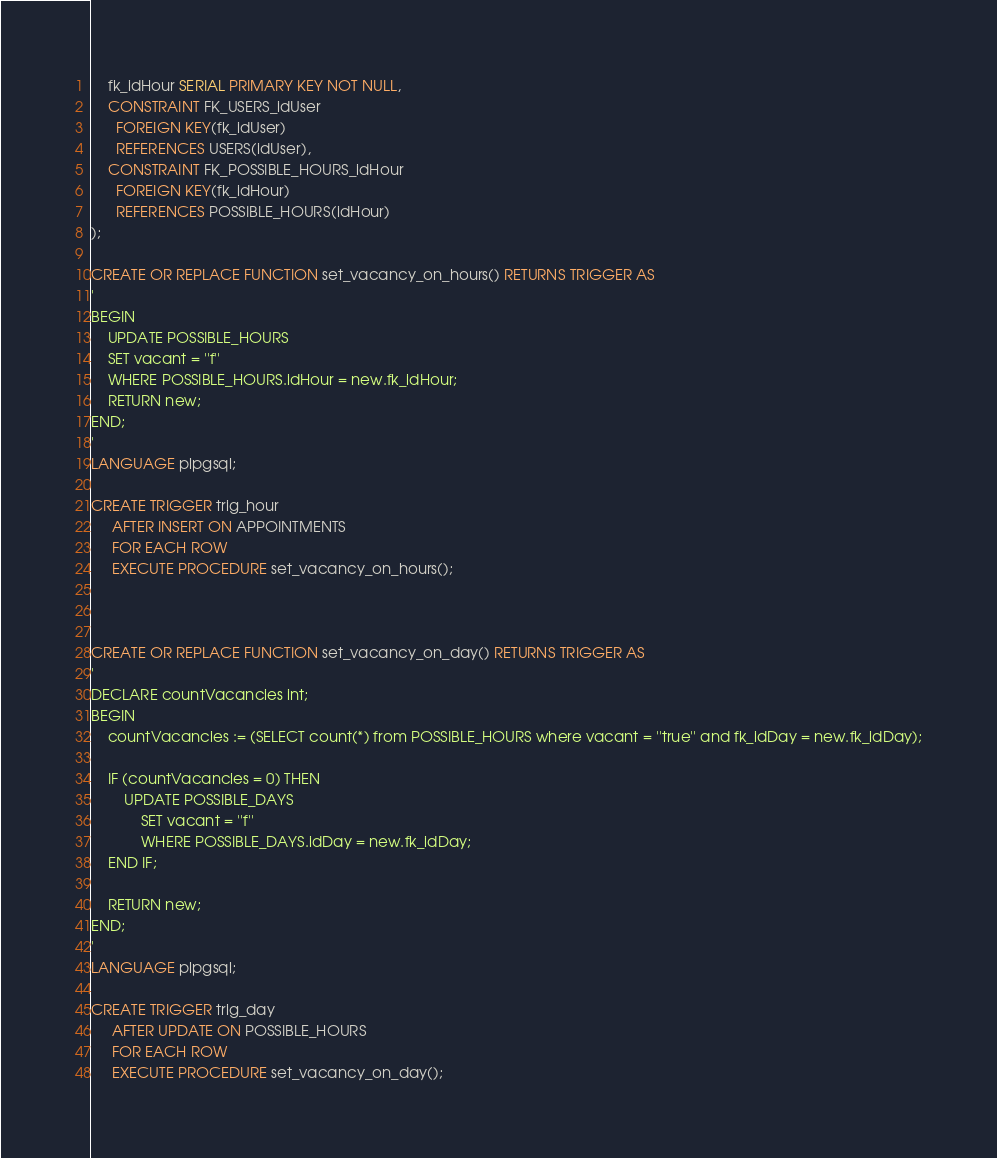<code> <loc_0><loc_0><loc_500><loc_500><_SQL_>    fk_idHour SERIAL PRIMARY KEY NOT NULL,
    CONSTRAINT FK_USERS_idUser
      FOREIGN KEY(fk_idUser)
      REFERENCES USERS(idUser),
    CONSTRAINT FK_POSSIBLE_HOURS_idHour
      FOREIGN KEY(fk_idHour)
      REFERENCES POSSIBLE_HOURS(idHour)
);

CREATE OR REPLACE FUNCTION set_vacancy_on_hours() RETURNS TRIGGER AS
'
BEGIN
    UPDATE POSSIBLE_HOURS
	SET vacant = ''f''
	WHERE POSSIBLE_HOURS.idHour = new.fk_idHour;
    RETURN new;
END;
'
LANGUAGE plpgsql;

CREATE TRIGGER trig_hour
     AFTER INSERT ON APPOINTMENTS
     FOR EACH ROW
     EXECUTE PROCEDURE set_vacancy_on_hours();



CREATE OR REPLACE FUNCTION set_vacancy_on_day() RETURNS TRIGGER AS
'
DECLARE countVacancies int;
BEGIN
    countVacancies := (SELECT count(*) from POSSIBLE_HOURS where vacant = ''true'' and fk_idDay = new.fk_idDay);
    
    IF (countVacancies = 0) THEN
        UPDATE POSSIBLE_DAYS
            SET vacant = ''f''
            WHERE POSSIBLE_DAYS.idDay = new.fk_idDay;
    END IF;
	
    RETURN new;
END;
'
LANGUAGE plpgsql;

CREATE TRIGGER trig_day
     AFTER UPDATE ON POSSIBLE_HOURS
     FOR EACH ROW
     EXECUTE PROCEDURE set_vacancy_on_day();
</code> 